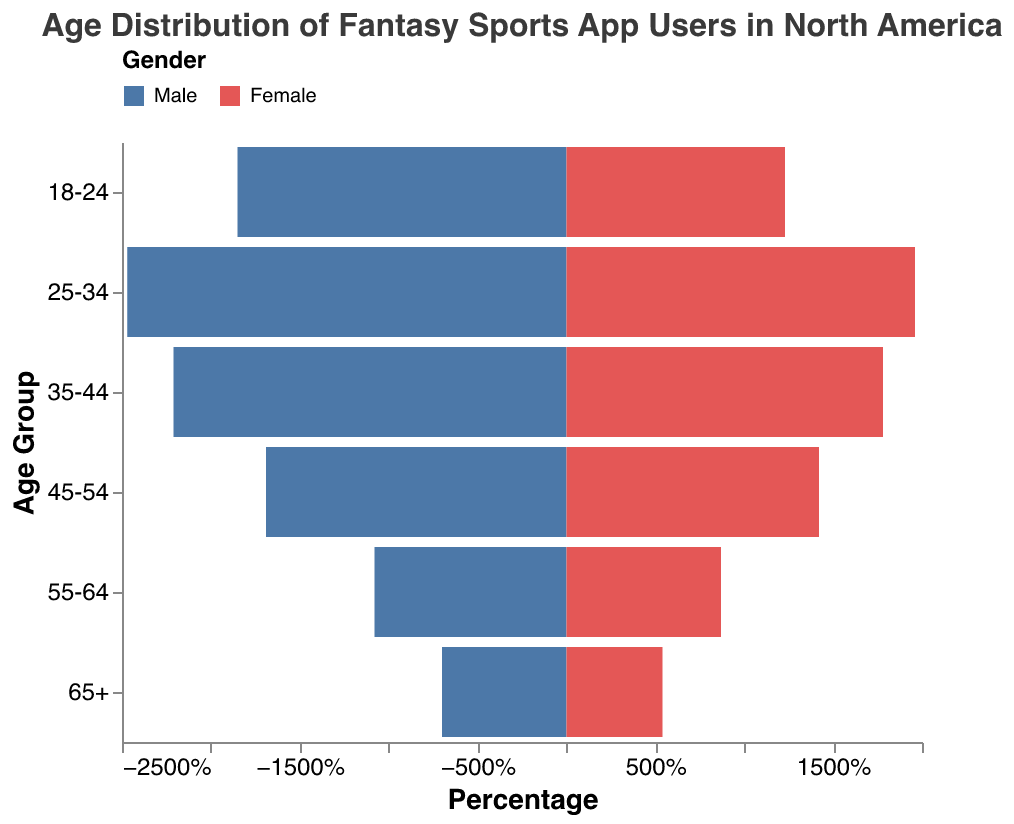What's the title of the figure? The title of the figure is displayed at the top and reads "Age Distribution of Fantasy Sports App Users in North America"
Answer: Age Distribution of Fantasy Sports App Users in North America How many age groups are presented in the figure? The figure presents six age groups, which can be identified by looking at the y-axis: "18-24", "25-34", "35-44", "45-54", "55-64", and "65+".
Answer: Six Which age group has the highest percentage of male users? By examining the left side of the population pyramid where male percentages are represented, the age group "25-34" has the highest bar length, meaning it has the highest percentage of male users.
Answer: 25-34 Is the percentage of female users in the "35-44" age group higher or lower than that in the "45-54" age group? Looking at the right side of the population pyramid, the bar for the "35-44" age group is longer than the bar for the "45-54" age group, indicating a higher percentage of female users in the "35-44" group.
Answer: Higher Which age group has the smallest disparity between male and female users? Disparity can be interpreted by the difference in bar lengths between genders. The age group "65+" has the smallest difference between the lengths of the male and female bars.
Answer: 65+ What is the total percentage of users aged between 18-24? The total percentage is calculated by summing the percentages of male and female users in the "18-24" age group. That is 18.5% (male) + 12.3% (female) = 30.8%.
Answer: 30.8% By how much does the percentage of male users aged 35-44 exceed that of users aged 55-64? The percentage of male users in the "35-44" age group is 22.1%, while in the "55-64" age group it is 10.8%. The difference is 22.1% - 10.8% = 11.3%.
Answer: 11.3% Which gender has a higher percentage in the 25-34 age group, and by how much? The percentage for males is 24.7% and for females is 19.6% in the "25-34" age group. Males have a higher percentage by 24.7% - 19.6% = 5.1%.
Answer: Males by 5.1% Based on the figure, does any age group have more female users than male users? By comparing the bar lengths of each age group, it is evident that in all age groups, male users have a longer bar, indicating a higher percentage. Therefore, no age group has more female users than male users.
Answer: No What's the average percentage of female users across all age groups? Calculate the average by summing the female percentages and dividing by the number of age groups: (12.3% + 19.6% + 17.8% + 14.2% + 8.7% + 5.4%) / 6 = 78.0% / 6 = 13.0%.
Answer: 13.0% 